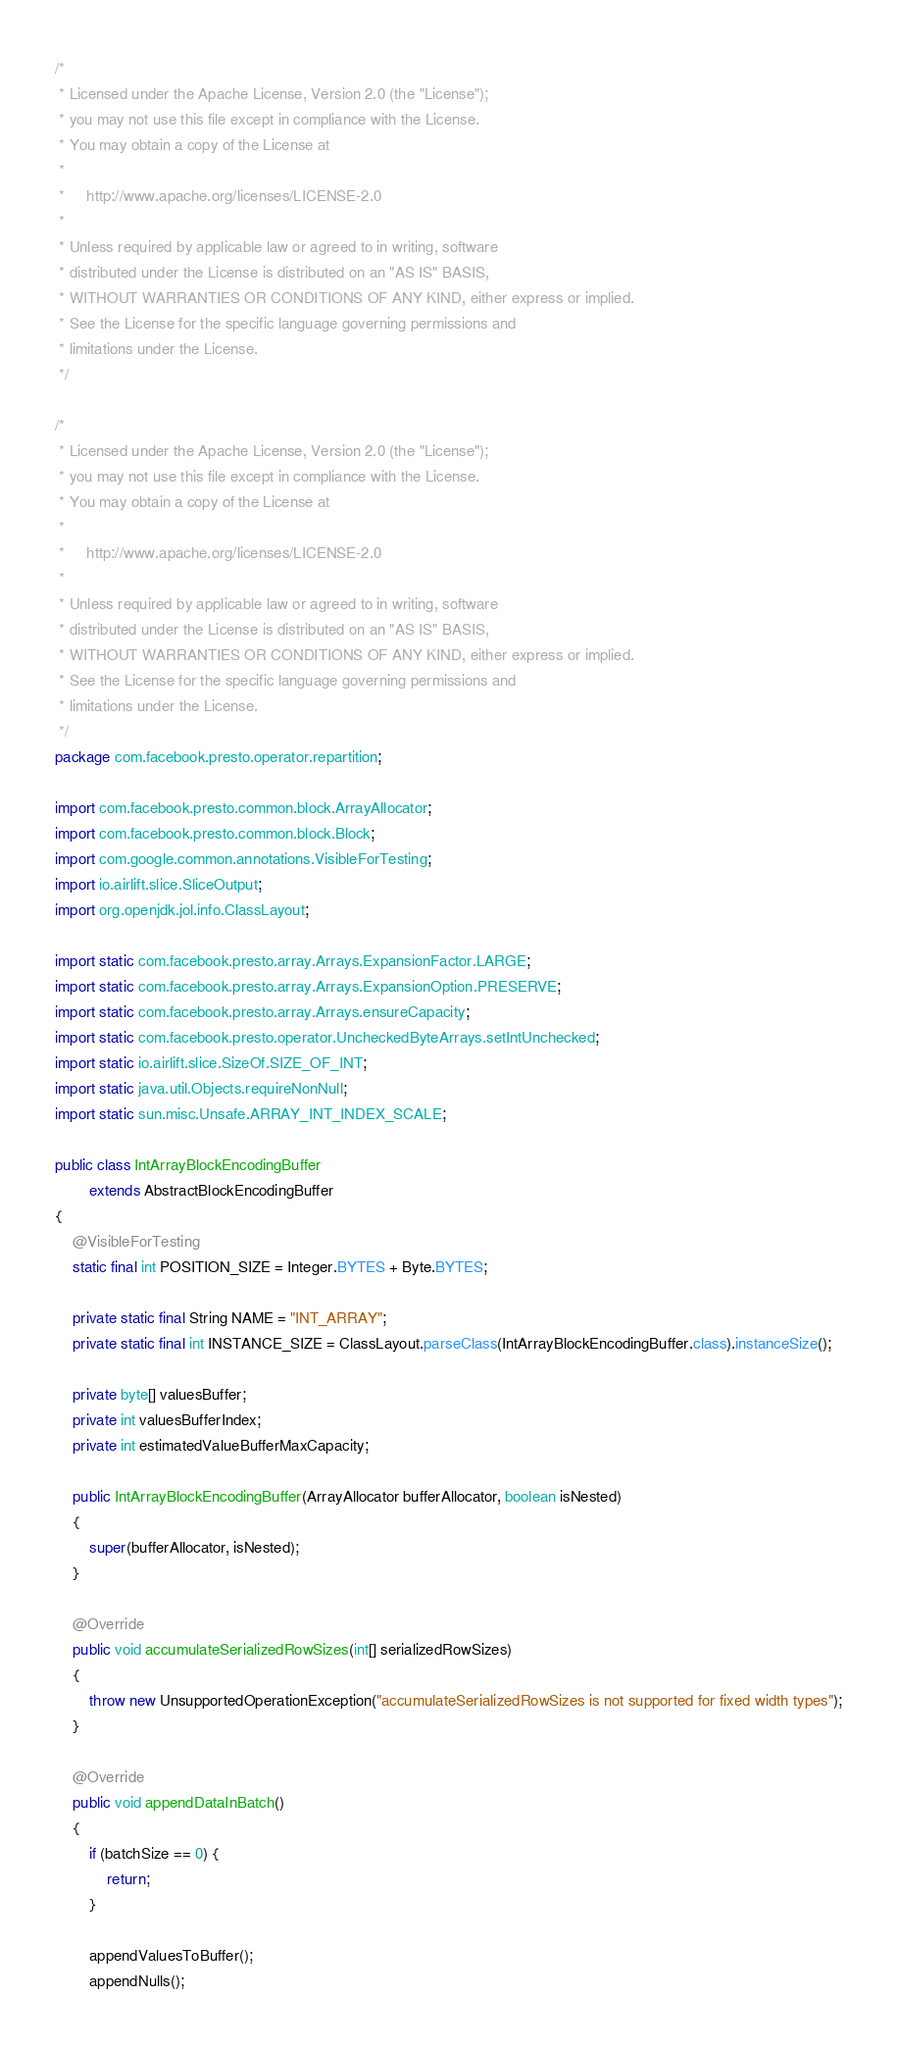<code> <loc_0><loc_0><loc_500><loc_500><_Java_>/*
 * Licensed under the Apache License, Version 2.0 (the "License");
 * you may not use this file except in compliance with the License.
 * You may obtain a copy of the License at
 *
 *     http://www.apache.org/licenses/LICENSE-2.0
 *
 * Unless required by applicable law or agreed to in writing, software
 * distributed under the License is distributed on an "AS IS" BASIS,
 * WITHOUT WARRANTIES OR CONDITIONS OF ANY KIND, either express or implied.
 * See the License for the specific language governing permissions and
 * limitations under the License.
 */

/*
 * Licensed under the Apache License, Version 2.0 (the "License");
 * you may not use this file except in compliance with the License.
 * You may obtain a copy of the License at
 *
 *     http://www.apache.org/licenses/LICENSE-2.0
 *
 * Unless required by applicable law or agreed to in writing, software
 * distributed under the License is distributed on an "AS IS" BASIS,
 * WITHOUT WARRANTIES OR CONDITIONS OF ANY KIND, either express or implied.
 * See the License for the specific language governing permissions and
 * limitations under the License.
 */
package com.facebook.presto.operator.repartition;

import com.facebook.presto.common.block.ArrayAllocator;
import com.facebook.presto.common.block.Block;
import com.google.common.annotations.VisibleForTesting;
import io.airlift.slice.SliceOutput;
import org.openjdk.jol.info.ClassLayout;

import static com.facebook.presto.array.Arrays.ExpansionFactor.LARGE;
import static com.facebook.presto.array.Arrays.ExpansionOption.PRESERVE;
import static com.facebook.presto.array.Arrays.ensureCapacity;
import static com.facebook.presto.operator.UncheckedByteArrays.setIntUnchecked;
import static io.airlift.slice.SizeOf.SIZE_OF_INT;
import static java.util.Objects.requireNonNull;
import static sun.misc.Unsafe.ARRAY_INT_INDEX_SCALE;

public class IntArrayBlockEncodingBuffer
        extends AbstractBlockEncodingBuffer
{
    @VisibleForTesting
    static final int POSITION_SIZE = Integer.BYTES + Byte.BYTES;

    private static final String NAME = "INT_ARRAY";
    private static final int INSTANCE_SIZE = ClassLayout.parseClass(IntArrayBlockEncodingBuffer.class).instanceSize();

    private byte[] valuesBuffer;
    private int valuesBufferIndex;
    private int estimatedValueBufferMaxCapacity;

    public IntArrayBlockEncodingBuffer(ArrayAllocator bufferAllocator, boolean isNested)
    {
        super(bufferAllocator, isNested);
    }

    @Override
    public void accumulateSerializedRowSizes(int[] serializedRowSizes)
    {
        throw new UnsupportedOperationException("accumulateSerializedRowSizes is not supported for fixed width types");
    }

    @Override
    public void appendDataInBatch()
    {
        if (batchSize == 0) {
            return;
        }

        appendValuesToBuffer();
        appendNulls();
</code> 